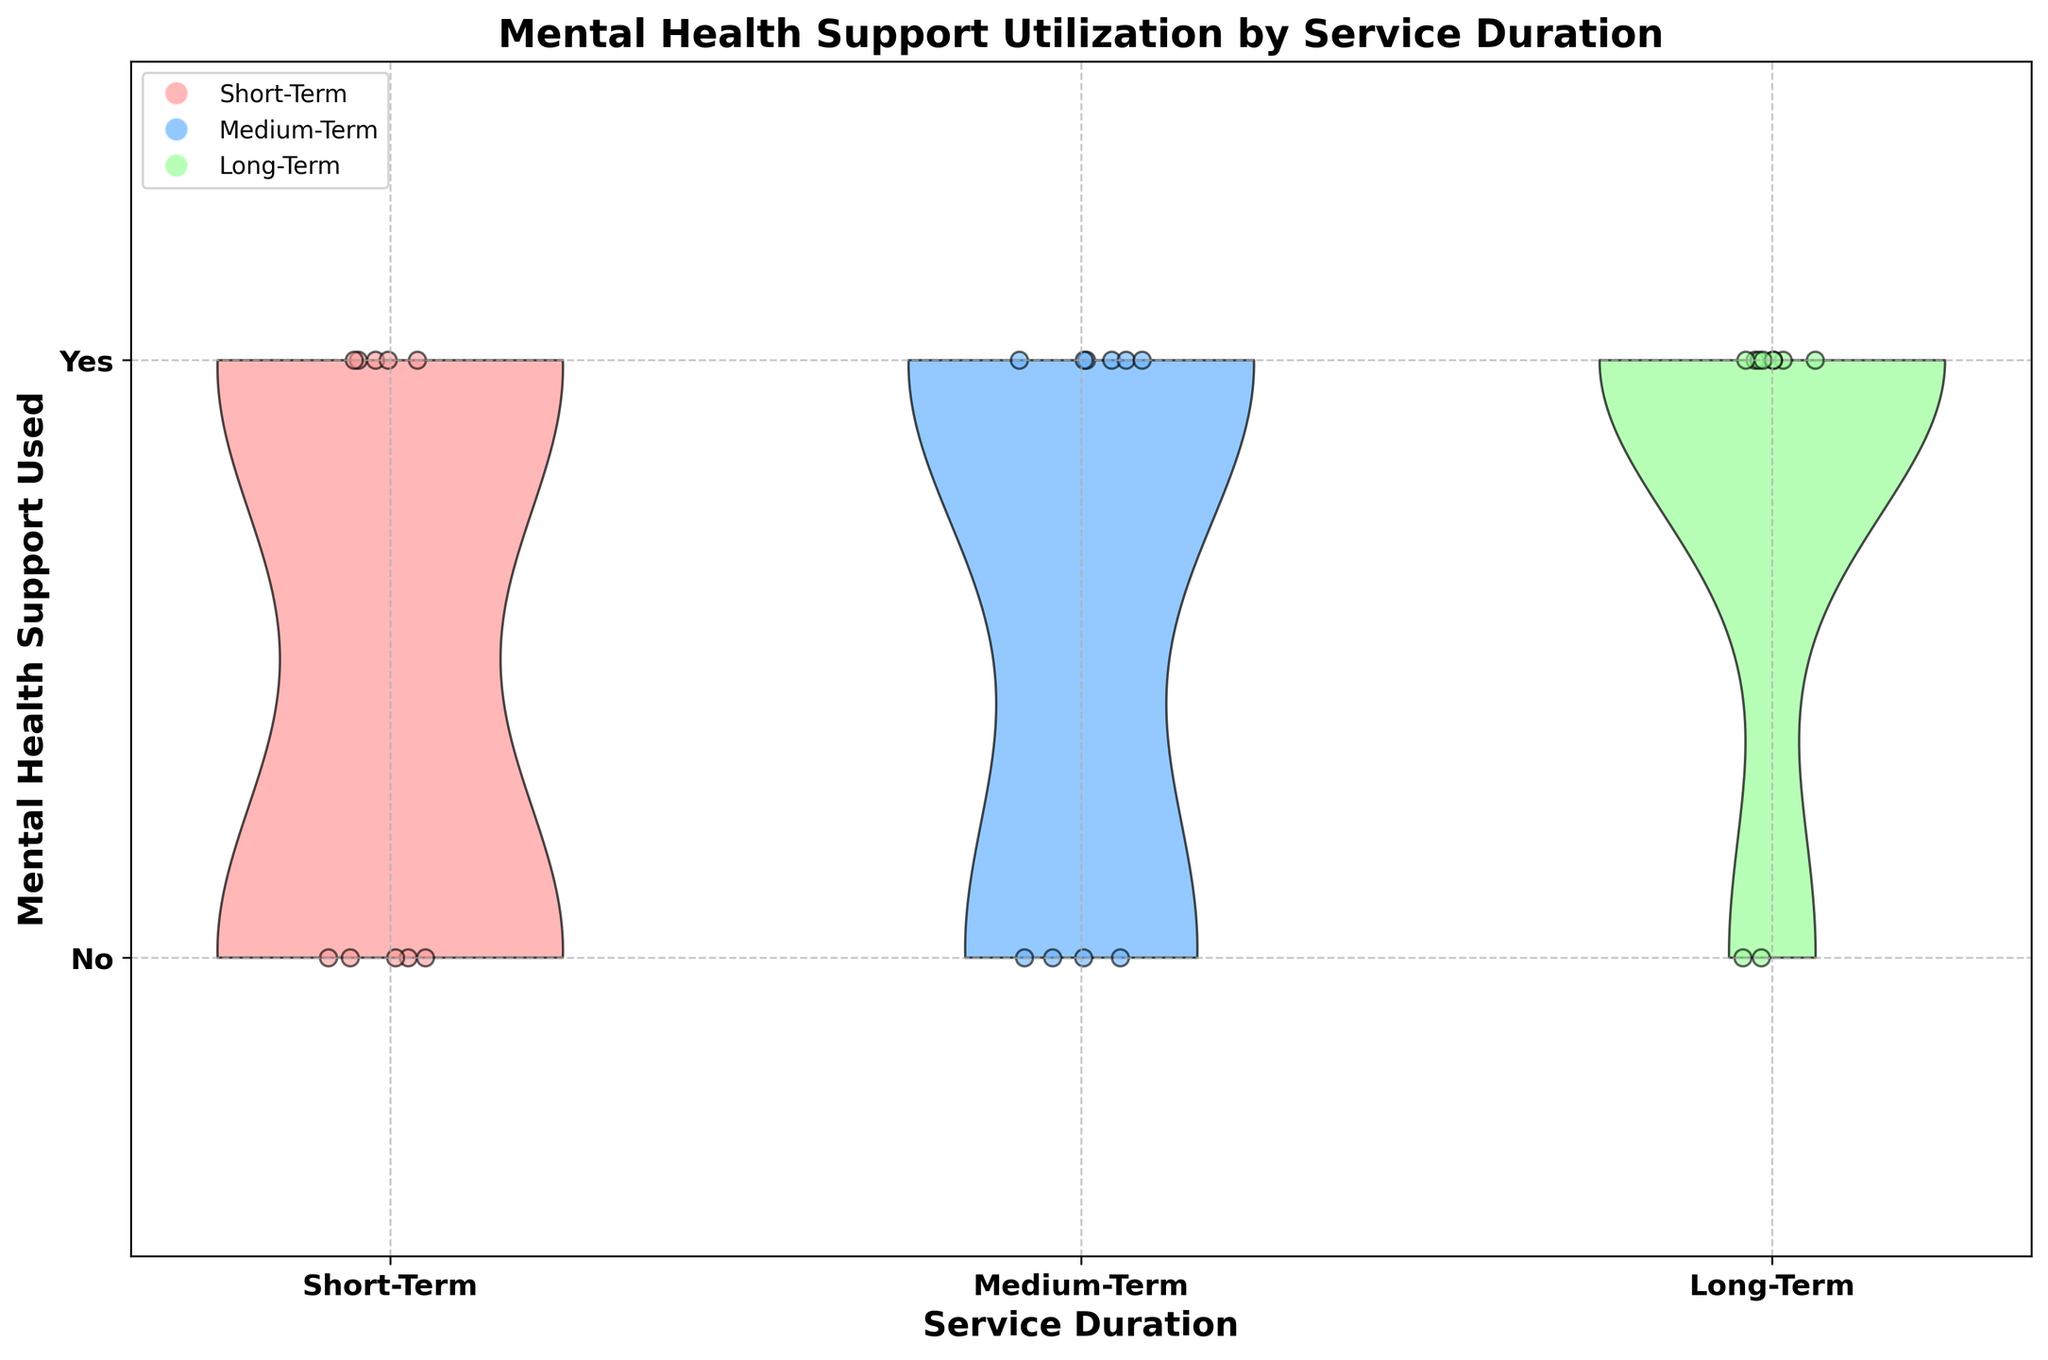What is the title of the figure? The title of the figure is printed at the top of the plot area. It states "Mental Health Support Utilization by Service Duration."
Answer: Mental Health Support Utilization by Service Duration How many categories of service duration are compared in this figure? The x-axis shows three distinct categories for service duration. These categories are "Short-Term," "Medium-Term," and "Long-Term."
Answer: 3 Which service duration category shows the highest frequency of mental health support usage? To determine this, look at the density and distribution of the 'Yes' values (1) visually represented by the height and width of the colored violin plots. The Long-Term category seems to have the highest frequency with a larger portion of the plot filled for 'Yes'.
Answer: Long-Term What are the different colors used in the violin plots and what do they represent? The violin plots use three different colors: one for each service duration category. Red represents Short-Term, blue represents Medium-Term, and green represents Long-Term.
Answer: Red for Short-Term, Blue for Medium-Term, Green for Long-Term Which service duration category has the least mental health support utilization? Look for the smallest proportion of 'Yes' values (1) in the violin plots. The Short-Term category has a smaller occupied area for 'Yes' values compared to Medium-Term and Long-Term.
Answer: Short-Term How do the distributions of mental health support utilization compare between Short-Term and Medium-Term categories? The Short-Term category has fewer 'Yes' values and more 'No' values compared to the Medium-Term category, which shows a nearly equal distribution of 'Yes' and 'No' values. This is visually evident from the relative widths of the violin plots for 'Yes' and 'No'.
Answer: Short-Term has fewer 'Yes' values than Medium-Term What is the most common response for mental health support usage in the Medium-Term category? By examining the distribution of values in the Medium-Term violin plot, it can be observed that both 'Yes' and 'No' values are almost equally common, but 'Yes' might slightly dominate.
Answer: Yes What pattern do you notice in the rate of mental health support utilization as service duration increases? As service duration increases from Short-Term to Long-Term, the usage of mental health support (represented by 'Yes') also increases. This can be seen with the increasing density of 'Yes' responses in the violin plots.
Answer: Support utilization increases with service duration What can be inferred about the consistency of mental health support utilization across different service durations? The Short-Term category shows more consistency with higher 'No' responses, while the Medium-Term and Long-Term categories show a higher variability and increased 'Yes' responses.
Answer: Higher consistency in Short-Term How does the individual therapy within the Long-Term category compare to individual therapies in the other categories? Based on individual data points noted as scatter plots, it is noticeable that there are more instances of individual therapy in the Long-Term category when compared to the other categories.
Answer: More instances in Long-Term 